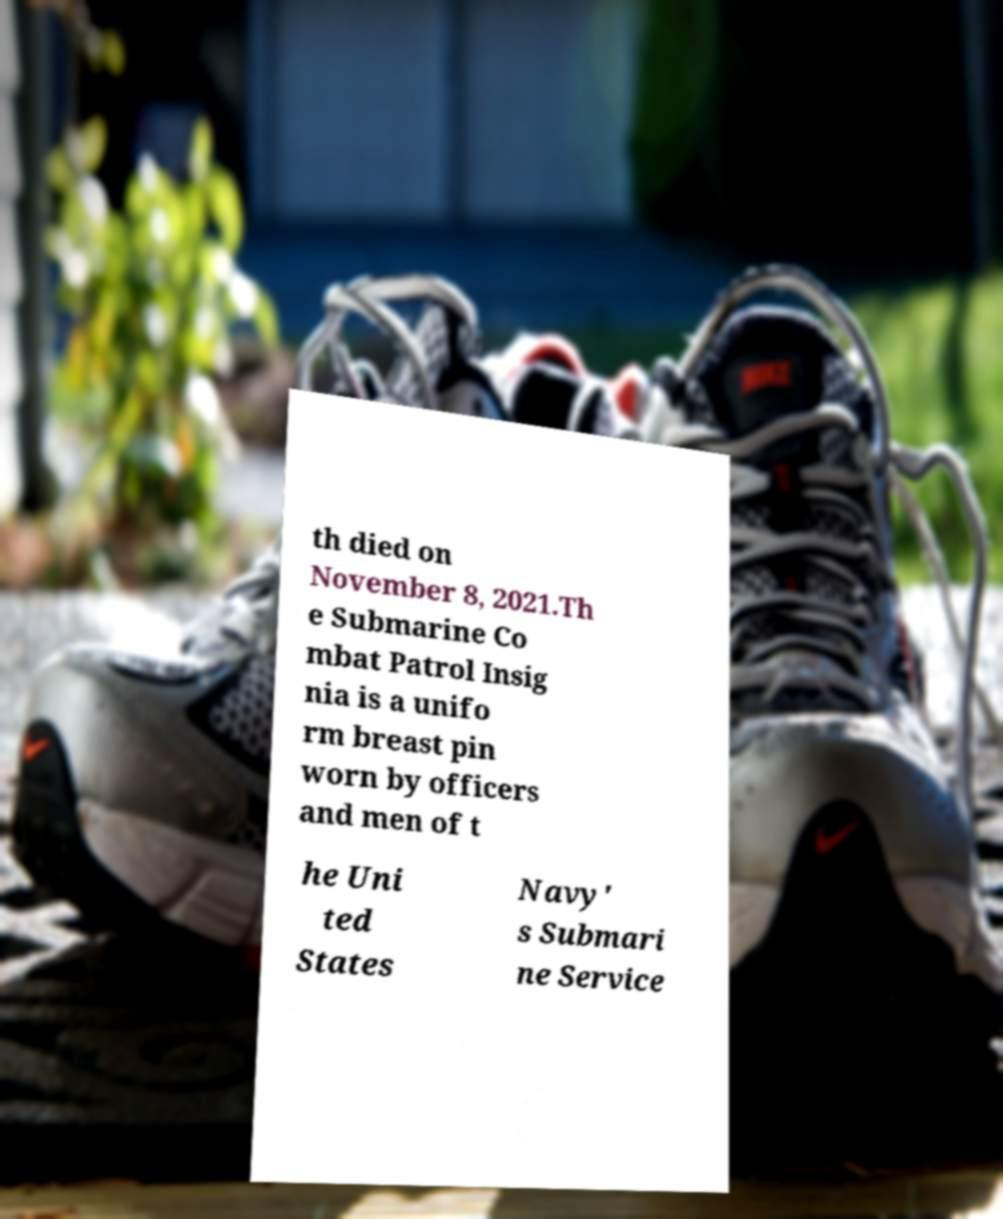Please identify and transcribe the text found in this image. th died on November 8, 2021.Th e Submarine Co mbat Patrol Insig nia is a unifo rm breast pin worn by officers and men of t he Uni ted States Navy' s Submari ne Service 